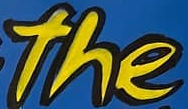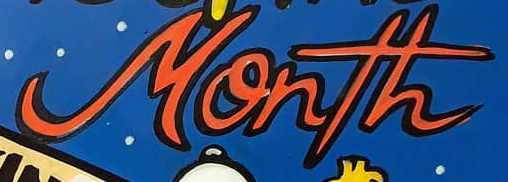Read the text content from these images in order, separated by a semicolon. the; Month 